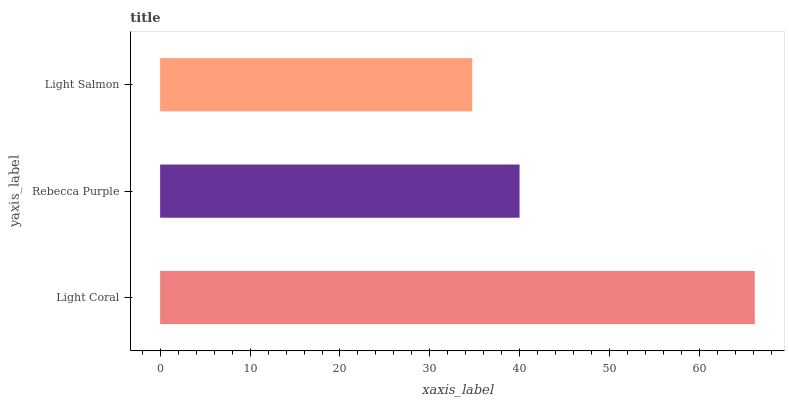Is Light Salmon the minimum?
Answer yes or no. Yes. Is Light Coral the maximum?
Answer yes or no. Yes. Is Rebecca Purple the minimum?
Answer yes or no. No. Is Rebecca Purple the maximum?
Answer yes or no. No. Is Light Coral greater than Rebecca Purple?
Answer yes or no. Yes. Is Rebecca Purple less than Light Coral?
Answer yes or no. Yes. Is Rebecca Purple greater than Light Coral?
Answer yes or no. No. Is Light Coral less than Rebecca Purple?
Answer yes or no. No. Is Rebecca Purple the high median?
Answer yes or no. Yes. Is Rebecca Purple the low median?
Answer yes or no. Yes. Is Light Salmon the high median?
Answer yes or no. No. Is Light Salmon the low median?
Answer yes or no. No. 